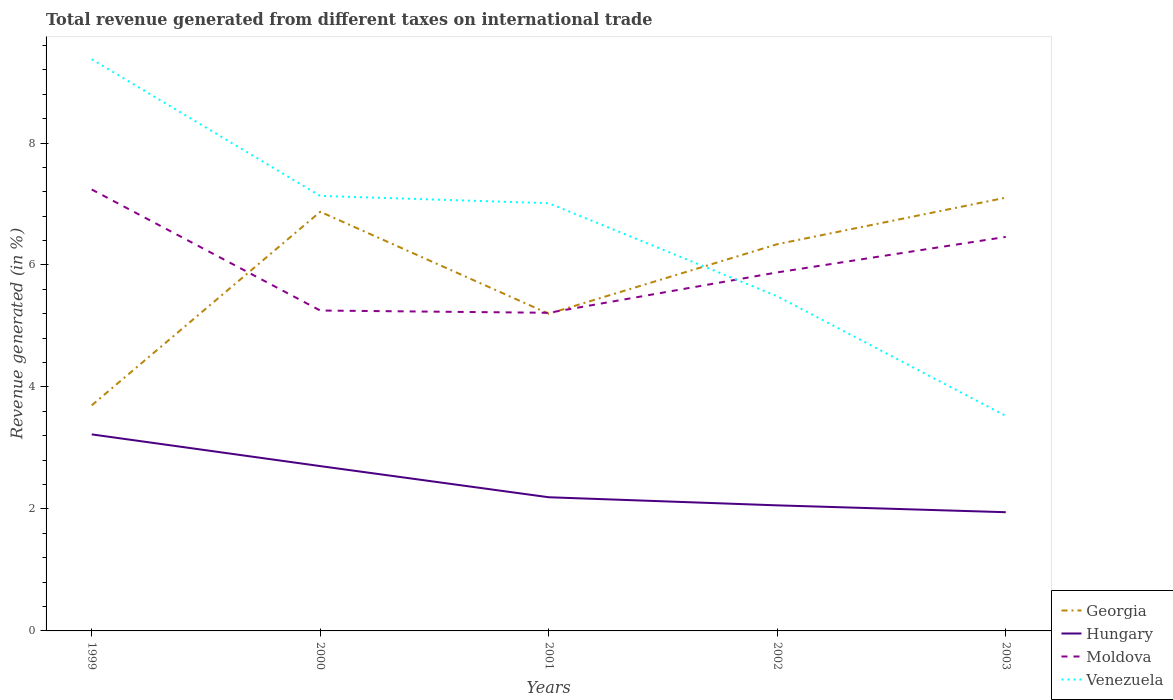How many different coloured lines are there?
Provide a succinct answer. 4. Does the line corresponding to Venezuela intersect with the line corresponding to Georgia?
Offer a terse response. Yes. Across all years, what is the maximum total revenue generated in Georgia?
Offer a very short reply. 3.7. What is the total total revenue generated in Moldova in the graph?
Give a very brief answer. 1.98. What is the difference between the highest and the second highest total revenue generated in Georgia?
Your answer should be compact. 3.41. What is the difference between the highest and the lowest total revenue generated in Venezuela?
Offer a terse response. 3. Is the total revenue generated in Venezuela strictly greater than the total revenue generated in Hungary over the years?
Make the answer very short. No. How many lines are there?
Your answer should be very brief. 4. Where does the legend appear in the graph?
Make the answer very short. Bottom right. How are the legend labels stacked?
Your response must be concise. Vertical. What is the title of the graph?
Give a very brief answer. Total revenue generated from different taxes on international trade. Does "Eritrea" appear as one of the legend labels in the graph?
Provide a short and direct response. No. What is the label or title of the X-axis?
Your response must be concise. Years. What is the label or title of the Y-axis?
Offer a very short reply. Revenue generated (in %). What is the Revenue generated (in %) in Georgia in 1999?
Make the answer very short. 3.7. What is the Revenue generated (in %) in Hungary in 1999?
Your answer should be very brief. 3.22. What is the Revenue generated (in %) in Moldova in 1999?
Your answer should be very brief. 7.24. What is the Revenue generated (in %) in Venezuela in 1999?
Your answer should be compact. 9.37. What is the Revenue generated (in %) in Georgia in 2000?
Your answer should be compact. 6.87. What is the Revenue generated (in %) in Hungary in 2000?
Give a very brief answer. 2.7. What is the Revenue generated (in %) in Moldova in 2000?
Keep it short and to the point. 5.25. What is the Revenue generated (in %) in Venezuela in 2000?
Keep it short and to the point. 7.13. What is the Revenue generated (in %) in Georgia in 2001?
Provide a succinct answer. 5.2. What is the Revenue generated (in %) of Hungary in 2001?
Keep it short and to the point. 2.19. What is the Revenue generated (in %) in Moldova in 2001?
Ensure brevity in your answer.  5.22. What is the Revenue generated (in %) in Venezuela in 2001?
Give a very brief answer. 7.01. What is the Revenue generated (in %) in Georgia in 2002?
Make the answer very short. 6.34. What is the Revenue generated (in %) of Hungary in 2002?
Your answer should be very brief. 2.06. What is the Revenue generated (in %) of Moldova in 2002?
Offer a terse response. 5.88. What is the Revenue generated (in %) of Venezuela in 2002?
Make the answer very short. 5.49. What is the Revenue generated (in %) of Georgia in 2003?
Keep it short and to the point. 7.1. What is the Revenue generated (in %) in Hungary in 2003?
Offer a terse response. 1.95. What is the Revenue generated (in %) of Moldova in 2003?
Offer a terse response. 6.46. What is the Revenue generated (in %) of Venezuela in 2003?
Provide a short and direct response. 3.53. Across all years, what is the maximum Revenue generated (in %) of Georgia?
Make the answer very short. 7.1. Across all years, what is the maximum Revenue generated (in %) in Hungary?
Your answer should be compact. 3.22. Across all years, what is the maximum Revenue generated (in %) in Moldova?
Offer a very short reply. 7.24. Across all years, what is the maximum Revenue generated (in %) of Venezuela?
Offer a very short reply. 9.37. Across all years, what is the minimum Revenue generated (in %) in Georgia?
Your answer should be very brief. 3.7. Across all years, what is the minimum Revenue generated (in %) in Hungary?
Give a very brief answer. 1.95. Across all years, what is the minimum Revenue generated (in %) in Moldova?
Offer a very short reply. 5.22. Across all years, what is the minimum Revenue generated (in %) of Venezuela?
Provide a short and direct response. 3.53. What is the total Revenue generated (in %) of Georgia in the graph?
Offer a terse response. 29.22. What is the total Revenue generated (in %) of Hungary in the graph?
Make the answer very short. 12.12. What is the total Revenue generated (in %) in Moldova in the graph?
Offer a very short reply. 30.05. What is the total Revenue generated (in %) in Venezuela in the graph?
Your answer should be very brief. 32.53. What is the difference between the Revenue generated (in %) in Georgia in 1999 and that in 2000?
Ensure brevity in your answer.  -3.17. What is the difference between the Revenue generated (in %) of Hungary in 1999 and that in 2000?
Make the answer very short. 0.52. What is the difference between the Revenue generated (in %) of Moldova in 1999 and that in 2000?
Ensure brevity in your answer.  1.98. What is the difference between the Revenue generated (in %) in Venezuela in 1999 and that in 2000?
Your answer should be very brief. 2.24. What is the difference between the Revenue generated (in %) of Georgia in 1999 and that in 2001?
Provide a succinct answer. -1.5. What is the difference between the Revenue generated (in %) of Hungary in 1999 and that in 2001?
Give a very brief answer. 1.03. What is the difference between the Revenue generated (in %) of Moldova in 1999 and that in 2001?
Make the answer very short. 2.02. What is the difference between the Revenue generated (in %) of Venezuela in 1999 and that in 2001?
Make the answer very short. 2.36. What is the difference between the Revenue generated (in %) in Georgia in 1999 and that in 2002?
Give a very brief answer. -2.64. What is the difference between the Revenue generated (in %) of Hungary in 1999 and that in 2002?
Offer a very short reply. 1.16. What is the difference between the Revenue generated (in %) in Moldova in 1999 and that in 2002?
Offer a terse response. 1.36. What is the difference between the Revenue generated (in %) of Venezuela in 1999 and that in 2002?
Make the answer very short. 3.89. What is the difference between the Revenue generated (in %) of Georgia in 1999 and that in 2003?
Offer a terse response. -3.41. What is the difference between the Revenue generated (in %) of Hungary in 1999 and that in 2003?
Give a very brief answer. 1.28. What is the difference between the Revenue generated (in %) of Moldova in 1999 and that in 2003?
Ensure brevity in your answer.  0.78. What is the difference between the Revenue generated (in %) of Venezuela in 1999 and that in 2003?
Give a very brief answer. 5.85. What is the difference between the Revenue generated (in %) in Georgia in 2000 and that in 2001?
Your answer should be compact. 1.67. What is the difference between the Revenue generated (in %) of Hungary in 2000 and that in 2001?
Offer a very short reply. 0.51. What is the difference between the Revenue generated (in %) in Moldova in 2000 and that in 2001?
Keep it short and to the point. 0.04. What is the difference between the Revenue generated (in %) in Venezuela in 2000 and that in 2001?
Make the answer very short. 0.12. What is the difference between the Revenue generated (in %) in Georgia in 2000 and that in 2002?
Keep it short and to the point. 0.53. What is the difference between the Revenue generated (in %) in Hungary in 2000 and that in 2002?
Ensure brevity in your answer.  0.64. What is the difference between the Revenue generated (in %) in Moldova in 2000 and that in 2002?
Your response must be concise. -0.63. What is the difference between the Revenue generated (in %) of Venezuela in 2000 and that in 2002?
Your answer should be compact. 1.65. What is the difference between the Revenue generated (in %) in Georgia in 2000 and that in 2003?
Give a very brief answer. -0.23. What is the difference between the Revenue generated (in %) of Hungary in 2000 and that in 2003?
Your answer should be compact. 0.76. What is the difference between the Revenue generated (in %) in Moldova in 2000 and that in 2003?
Offer a terse response. -1.21. What is the difference between the Revenue generated (in %) in Venezuela in 2000 and that in 2003?
Provide a succinct answer. 3.61. What is the difference between the Revenue generated (in %) of Georgia in 2001 and that in 2002?
Keep it short and to the point. -1.14. What is the difference between the Revenue generated (in %) in Hungary in 2001 and that in 2002?
Provide a short and direct response. 0.13. What is the difference between the Revenue generated (in %) in Moldova in 2001 and that in 2002?
Your answer should be compact. -0.66. What is the difference between the Revenue generated (in %) of Venezuela in 2001 and that in 2002?
Provide a succinct answer. 1.53. What is the difference between the Revenue generated (in %) in Georgia in 2001 and that in 2003?
Give a very brief answer. -1.9. What is the difference between the Revenue generated (in %) of Hungary in 2001 and that in 2003?
Provide a short and direct response. 0.25. What is the difference between the Revenue generated (in %) of Moldova in 2001 and that in 2003?
Your response must be concise. -1.24. What is the difference between the Revenue generated (in %) in Venezuela in 2001 and that in 2003?
Provide a short and direct response. 3.49. What is the difference between the Revenue generated (in %) of Georgia in 2002 and that in 2003?
Your response must be concise. -0.76. What is the difference between the Revenue generated (in %) in Hungary in 2002 and that in 2003?
Your answer should be very brief. 0.11. What is the difference between the Revenue generated (in %) in Moldova in 2002 and that in 2003?
Keep it short and to the point. -0.58. What is the difference between the Revenue generated (in %) in Venezuela in 2002 and that in 2003?
Make the answer very short. 1.96. What is the difference between the Revenue generated (in %) of Georgia in 1999 and the Revenue generated (in %) of Hungary in 2000?
Make the answer very short. 1. What is the difference between the Revenue generated (in %) of Georgia in 1999 and the Revenue generated (in %) of Moldova in 2000?
Ensure brevity in your answer.  -1.55. What is the difference between the Revenue generated (in %) in Georgia in 1999 and the Revenue generated (in %) in Venezuela in 2000?
Your answer should be compact. -3.43. What is the difference between the Revenue generated (in %) of Hungary in 1999 and the Revenue generated (in %) of Moldova in 2000?
Your response must be concise. -2.03. What is the difference between the Revenue generated (in %) in Hungary in 1999 and the Revenue generated (in %) in Venezuela in 2000?
Your response must be concise. -3.91. What is the difference between the Revenue generated (in %) of Moldova in 1999 and the Revenue generated (in %) of Venezuela in 2000?
Your answer should be compact. 0.11. What is the difference between the Revenue generated (in %) of Georgia in 1999 and the Revenue generated (in %) of Hungary in 2001?
Make the answer very short. 1.51. What is the difference between the Revenue generated (in %) in Georgia in 1999 and the Revenue generated (in %) in Moldova in 2001?
Make the answer very short. -1.52. What is the difference between the Revenue generated (in %) of Georgia in 1999 and the Revenue generated (in %) of Venezuela in 2001?
Make the answer very short. -3.31. What is the difference between the Revenue generated (in %) of Hungary in 1999 and the Revenue generated (in %) of Moldova in 2001?
Give a very brief answer. -1.99. What is the difference between the Revenue generated (in %) in Hungary in 1999 and the Revenue generated (in %) in Venezuela in 2001?
Offer a terse response. -3.79. What is the difference between the Revenue generated (in %) in Moldova in 1999 and the Revenue generated (in %) in Venezuela in 2001?
Give a very brief answer. 0.22. What is the difference between the Revenue generated (in %) in Georgia in 1999 and the Revenue generated (in %) in Hungary in 2002?
Offer a terse response. 1.64. What is the difference between the Revenue generated (in %) of Georgia in 1999 and the Revenue generated (in %) of Moldova in 2002?
Make the answer very short. -2.18. What is the difference between the Revenue generated (in %) in Georgia in 1999 and the Revenue generated (in %) in Venezuela in 2002?
Offer a terse response. -1.79. What is the difference between the Revenue generated (in %) of Hungary in 1999 and the Revenue generated (in %) of Moldova in 2002?
Ensure brevity in your answer.  -2.66. What is the difference between the Revenue generated (in %) of Hungary in 1999 and the Revenue generated (in %) of Venezuela in 2002?
Your response must be concise. -2.26. What is the difference between the Revenue generated (in %) of Moldova in 1999 and the Revenue generated (in %) of Venezuela in 2002?
Offer a very short reply. 1.75. What is the difference between the Revenue generated (in %) of Georgia in 1999 and the Revenue generated (in %) of Hungary in 2003?
Your answer should be compact. 1.75. What is the difference between the Revenue generated (in %) of Georgia in 1999 and the Revenue generated (in %) of Moldova in 2003?
Provide a short and direct response. -2.76. What is the difference between the Revenue generated (in %) of Georgia in 1999 and the Revenue generated (in %) of Venezuela in 2003?
Your answer should be very brief. 0.17. What is the difference between the Revenue generated (in %) of Hungary in 1999 and the Revenue generated (in %) of Moldova in 2003?
Provide a short and direct response. -3.24. What is the difference between the Revenue generated (in %) in Hungary in 1999 and the Revenue generated (in %) in Venezuela in 2003?
Keep it short and to the point. -0.3. What is the difference between the Revenue generated (in %) in Moldova in 1999 and the Revenue generated (in %) in Venezuela in 2003?
Ensure brevity in your answer.  3.71. What is the difference between the Revenue generated (in %) in Georgia in 2000 and the Revenue generated (in %) in Hungary in 2001?
Your answer should be very brief. 4.68. What is the difference between the Revenue generated (in %) of Georgia in 2000 and the Revenue generated (in %) of Moldova in 2001?
Ensure brevity in your answer.  1.66. What is the difference between the Revenue generated (in %) of Georgia in 2000 and the Revenue generated (in %) of Venezuela in 2001?
Your answer should be compact. -0.14. What is the difference between the Revenue generated (in %) in Hungary in 2000 and the Revenue generated (in %) in Moldova in 2001?
Offer a terse response. -2.51. What is the difference between the Revenue generated (in %) in Hungary in 2000 and the Revenue generated (in %) in Venezuela in 2001?
Provide a succinct answer. -4.31. What is the difference between the Revenue generated (in %) of Moldova in 2000 and the Revenue generated (in %) of Venezuela in 2001?
Give a very brief answer. -1.76. What is the difference between the Revenue generated (in %) of Georgia in 2000 and the Revenue generated (in %) of Hungary in 2002?
Your response must be concise. 4.81. What is the difference between the Revenue generated (in %) in Georgia in 2000 and the Revenue generated (in %) in Moldova in 2002?
Provide a succinct answer. 0.99. What is the difference between the Revenue generated (in %) of Georgia in 2000 and the Revenue generated (in %) of Venezuela in 2002?
Offer a very short reply. 1.39. What is the difference between the Revenue generated (in %) of Hungary in 2000 and the Revenue generated (in %) of Moldova in 2002?
Provide a short and direct response. -3.18. What is the difference between the Revenue generated (in %) of Hungary in 2000 and the Revenue generated (in %) of Venezuela in 2002?
Your response must be concise. -2.78. What is the difference between the Revenue generated (in %) of Moldova in 2000 and the Revenue generated (in %) of Venezuela in 2002?
Your answer should be very brief. -0.23. What is the difference between the Revenue generated (in %) of Georgia in 2000 and the Revenue generated (in %) of Hungary in 2003?
Your answer should be very brief. 4.93. What is the difference between the Revenue generated (in %) of Georgia in 2000 and the Revenue generated (in %) of Moldova in 2003?
Keep it short and to the point. 0.41. What is the difference between the Revenue generated (in %) in Georgia in 2000 and the Revenue generated (in %) in Venezuela in 2003?
Your answer should be compact. 3.35. What is the difference between the Revenue generated (in %) in Hungary in 2000 and the Revenue generated (in %) in Moldova in 2003?
Your answer should be very brief. -3.76. What is the difference between the Revenue generated (in %) of Hungary in 2000 and the Revenue generated (in %) of Venezuela in 2003?
Your answer should be very brief. -0.82. What is the difference between the Revenue generated (in %) in Moldova in 2000 and the Revenue generated (in %) in Venezuela in 2003?
Keep it short and to the point. 1.73. What is the difference between the Revenue generated (in %) of Georgia in 2001 and the Revenue generated (in %) of Hungary in 2002?
Provide a succinct answer. 3.14. What is the difference between the Revenue generated (in %) of Georgia in 2001 and the Revenue generated (in %) of Moldova in 2002?
Ensure brevity in your answer.  -0.68. What is the difference between the Revenue generated (in %) in Georgia in 2001 and the Revenue generated (in %) in Venezuela in 2002?
Your answer should be very brief. -0.29. What is the difference between the Revenue generated (in %) of Hungary in 2001 and the Revenue generated (in %) of Moldova in 2002?
Your answer should be compact. -3.69. What is the difference between the Revenue generated (in %) of Hungary in 2001 and the Revenue generated (in %) of Venezuela in 2002?
Give a very brief answer. -3.29. What is the difference between the Revenue generated (in %) of Moldova in 2001 and the Revenue generated (in %) of Venezuela in 2002?
Offer a terse response. -0.27. What is the difference between the Revenue generated (in %) in Georgia in 2001 and the Revenue generated (in %) in Hungary in 2003?
Give a very brief answer. 3.25. What is the difference between the Revenue generated (in %) of Georgia in 2001 and the Revenue generated (in %) of Moldova in 2003?
Give a very brief answer. -1.26. What is the difference between the Revenue generated (in %) in Georgia in 2001 and the Revenue generated (in %) in Venezuela in 2003?
Your answer should be compact. 1.67. What is the difference between the Revenue generated (in %) of Hungary in 2001 and the Revenue generated (in %) of Moldova in 2003?
Give a very brief answer. -4.27. What is the difference between the Revenue generated (in %) in Hungary in 2001 and the Revenue generated (in %) in Venezuela in 2003?
Offer a terse response. -1.33. What is the difference between the Revenue generated (in %) in Moldova in 2001 and the Revenue generated (in %) in Venezuela in 2003?
Offer a very short reply. 1.69. What is the difference between the Revenue generated (in %) in Georgia in 2002 and the Revenue generated (in %) in Hungary in 2003?
Provide a succinct answer. 4.39. What is the difference between the Revenue generated (in %) of Georgia in 2002 and the Revenue generated (in %) of Moldova in 2003?
Make the answer very short. -0.12. What is the difference between the Revenue generated (in %) in Georgia in 2002 and the Revenue generated (in %) in Venezuela in 2003?
Ensure brevity in your answer.  2.82. What is the difference between the Revenue generated (in %) of Hungary in 2002 and the Revenue generated (in %) of Moldova in 2003?
Offer a terse response. -4.4. What is the difference between the Revenue generated (in %) in Hungary in 2002 and the Revenue generated (in %) in Venezuela in 2003?
Your answer should be compact. -1.47. What is the difference between the Revenue generated (in %) of Moldova in 2002 and the Revenue generated (in %) of Venezuela in 2003?
Your answer should be compact. 2.35. What is the average Revenue generated (in %) of Georgia per year?
Provide a succinct answer. 5.84. What is the average Revenue generated (in %) of Hungary per year?
Keep it short and to the point. 2.42. What is the average Revenue generated (in %) of Moldova per year?
Offer a very short reply. 6.01. What is the average Revenue generated (in %) in Venezuela per year?
Provide a short and direct response. 6.51. In the year 1999, what is the difference between the Revenue generated (in %) of Georgia and Revenue generated (in %) of Hungary?
Provide a succinct answer. 0.48. In the year 1999, what is the difference between the Revenue generated (in %) of Georgia and Revenue generated (in %) of Moldova?
Provide a short and direct response. -3.54. In the year 1999, what is the difference between the Revenue generated (in %) in Georgia and Revenue generated (in %) in Venezuela?
Give a very brief answer. -5.68. In the year 1999, what is the difference between the Revenue generated (in %) in Hungary and Revenue generated (in %) in Moldova?
Provide a short and direct response. -4.02. In the year 1999, what is the difference between the Revenue generated (in %) of Hungary and Revenue generated (in %) of Venezuela?
Your answer should be compact. -6.15. In the year 1999, what is the difference between the Revenue generated (in %) of Moldova and Revenue generated (in %) of Venezuela?
Offer a very short reply. -2.14. In the year 2000, what is the difference between the Revenue generated (in %) in Georgia and Revenue generated (in %) in Hungary?
Your answer should be compact. 4.17. In the year 2000, what is the difference between the Revenue generated (in %) in Georgia and Revenue generated (in %) in Moldova?
Your answer should be compact. 1.62. In the year 2000, what is the difference between the Revenue generated (in %) in Georgia and Revenue generated (in %) in Venezuela?
Provide a short and direct response. -0.26. In the year 2000, what is the difference between the Revenue generated (in %) in Hungary and Revenue generated (in %) in Moldova?
Offer a very short reply. -2.55. In the year 2000, what is the difference between the Revenue generated (in %) of Hungary and Revenue generated (in %) of Venezuela?
Your answer should be very brief. -4.43. In the year 2000, what is the difference between the Revenue generated (in %) of Moldova and Revenue generated (in %) of Venezuela?
Your response must be concise. -1.88. In the year 2001, what is the difference between the Revenue generated (in %) in Georgia and Revenue generated (in %) in Hungary?
Your response must be concise. 3.01. In the year 2001, what is the difference between the Revenue generated (in %) in Georgia and Revenue generated (in %) in Moldova?
Your answer should be compact. -0.02. In the year 2001, what is the difference between the Revenue generated (in %) in Georgia and Revenue generated (in %) in Venezuela?
Make the answer very short. -1.81. In the year 2001, what is the difference between the Revenue generated (in %) in Hungary and Revenue generated (in %) in Moldova?
Provide a succinct answer. -3.02. In the year 2001, what is the difference between the Revenue generated (in %) of Hungary and Revenue generated (in %) of Venezuela?
Keep it short and to the point. -4.82. In the year 2001, what is the difference between the Revenue generated (in %) in Moldova and Revenue generated (in %) in Venezuela?
Your answer should be compact. -1.8. In the year 2002, what is the difference between the Revenue generated (in %) in Georgia and Revenue generated (in %) in Hungary?
Provide a short and direct response. 4.28. In the year 2002, what is the difference between the Revenue generated (in %) of Georgia and Revenue generated (in %) of Moldova?
Give a very brief answer. 0.46. In the year 2002, what is the difference between the Revenue generated (in %) in Georgia and Revenue generated (in %) in Venezuela?
Make the answer very short. 0.85. In the year 2002, what is the difference between the Revenue generated (in %) in Hungary and Revenue generated (in %) in Moldova?
Offer a terse response. -3.82. In the year 2002, what is the difference between the Revenue generated (in %) in Hungary and Revenue generated (in %) in Venezuela?
Your answer should be compact. -3.43. In the year 2002, what is the difference between the Revenue generated (in %) in Moldova and Revenue generated (in %) in Venezuela?
Offer a terse response. 0.39. In the year 2003, what is the difference between the Revenue generated (in %) of Georgia and Revenue generated (in %) of Hungary?
Ensure brevity in your answer.  5.16. In the year 2003, what is the difference between the Revenue generated (in %) of Georgia and Revenue generated (in %) of Moldova?
Ensure brevity in your answer.  0.64. In the year 2003, what is the difference between the Revenue generated (in %) in Georgia and Revenue generated (in %) in Venezuela?
Your response must be concise. 3.58. In the year 2003, what is the difference between the Revenue generated (in %) in Hungary and Revenue generated (in %) in Moldova?
Offer a very short reply. -4.51. In the year 2003, what is the difference between the Revenue generated (in %) of Hungary and Revenue generated (in %) of Venezuela?
Your answer should be very brief. -1.58. In the year 2003, what is the difference between the Revenue generated (in %) of Moldova and Revenue generated (in %) of Venezuela?
Provide a succinct answer. 2.93. What is the ratio of the Revenue generated (in %) of Georgia in 1999 to that in 2000?
Give a very brief answer. 0.54. What is the ratio of the Revenue generated (in %) of Hungary in 1999 to that in 2000?
Provide a short and direct response. 1.19. What is the ratio of the Revenue generated (in %) in Moldova in 1999 to that in 2000?
Your response must be concise. 1.38. What is the ratio of the Revenue generated (in %) in Venezuela in 1999 to that in 2000?
Your response must be concise. 1.31. What is the ratio of the Revenue generated (in %) in Georgia in 1999 to that in 2001?
Ensure brevity in your answer.  0.71. What is the ratio of the Revenue generated (in %) of Hungary in 1999 to that in 2001?
Offer a terse response. 1.47. What is the ratio of the Revenue generated (in %) of Moldova in 1999 to that in 2001?
Offer a terse response. 1.39. What is the ratio of the Revenue generated (in %) of Venezuela in 1999 to that in 2001?
Your answer should be very brief. 1.34. What is the ratio of the Revenue generated (in %) in Georgia in 1999 to that in 2002?
Your answer should be compact. 0.58. What is the ratio of the Revenue generated (in %) in Hungary in 1999 to that in 2002?
Make the answer very short. 1.57. What is the ratio of the Revenue generated (in %) in Moldova in 1999 to that in 2002?
Your answer should be compact. 1.23. What is the ratio of the Revenue generated (in %) of Venezuela in 1999 to that in 2002?
Provide a short and direct response. 1.71. What is the ratio of the Revenue generated (in %) in Georgia in 1999 to that in 2003?
Make the answer very short. 0.52. What is the ratio of the Revenue generated (in %) of Hungary in 1999 to that in 2003?
Give a very brief answer. 1.66. What is the ratio of the Revenue generated (in %) of Moldova in 1999 to that in 2003?
Ensure brevity in your answer.  1.12. What is the ratio of the Revenue generated (in %) in Venezuela in 1999 to that in 2003?
Keep it short and to the point. 2.66. What is the ratio of the Revenue generated (in %) in Georgia in 2000 to that in 2001?
Your response must be concise. 1.32. What is the ratio of the Revenue generated (in %) in Hungary in 2000 to that in 2001?
Provide a short and direct response. 1.23. What is the ratio of the Revenue generated (in %) in Moldova in 2000 to that in 2001?
Offer a terse response. 1.01. What is the ratio of the Revenue generated (in %) of Georgia in 2000 to that in 2002?
Offer a terse response. 1.08. What is the ratio of the Revenue generated (in %) in Hungary in 2000 to that in 2002?
Make the answer very short. 1.31. What is the ratio of the Revenue generated (in %) of Moldova in 2000 to that in 2002?
Ensure brevity in your answer.  0.89. What is the ratio of the Revenue generated (in %) of Venezuela in 2000 to that in 2002?
Keep it short and to the point. 1.3. What is the ratio of the Revenue generated (in %) of Georgia in 2000 to that in 2003?
Make the answer very short. 0.97. What is the ratio of the Revenue generated (in %) in Hungary in 2000 to that in 2003?
Your answer should be very brief. 1.39. What is the ratio of the Revenue generated (in %) in Moldova in 2000 to that in 2003?
Offer a terse response. 0.81. What is the ratio of the Revenue generated (in %) in Venezuela in 2000 to that in 2003?
Ensure brevity in your answer.  2.02. What is the ratio of the Revenue generated (in %) in Georgia in 2001 to that in 2002?
Make the answer very short. 0.82. What is the ratio of the Revenue generated (in %) in Hungary in 2001 to that in 2002?
Give a very brief answer. 1.06. What is the ratio of the Revenue generated (in %) of Moldova in 2001 to that in 2002?
Your response must be concise. 0.89. What is the ratio of the Revenue generated (in %) in Venezuela in 2001 to that in 2002?
Keep it short and to the point. 1.28. What is the ratio of the Revenue generated (in %) of Georgia in 2001 to that in 2003?
Ensure brevity in your answer.  0.73. What is the ratio of the Revenue generated (in %) of Hungary in 2001 to that in 2003?
Ensure brevity in your answer.  1.13. What is the ratio of the Revenue generated (in %) of Moldova in 2001 to that in 2003?
Offer a very short reply. 0.81. What is the ratio of the Revenue generated (in %) of Venezuela in 2001 to that in 2003?
Give a very brief answer. 1.99. What is the ratio of the Revenue generated (in %) in Georgia in 2002 to that in 2003?
Provide a succinct answer. 0.89. What is the ratio of the Revenue generated (in %) of Hungary in 2002 to that in 2003?
Ensure brevity in your answer.  1.06. What is the ratio of the Revenue generated (in %) of Moldova in 2002 to that in 2003?
Make the answer very short. 0.91. What is the ratio of the Revenue generated (in %) in Venezuela in 2002 to that in 2003?
Offer a very short reply. 1.56. What is the difference between the highest and the second highest Revenue generated (in %) in Georgia?
Keep it short and to the point. 0.23. What is the difference between the highest and the second highest Revenue generated (in %) of Hungary?
Offer a terse response. 0.52. What is the difference between the highest and the second highest Revenue generated (in %) in Moldova?
Provide a short and direct response. 0.78. What is the difference between the highest and the second highest Revenue generated (in %) in Venezuela?
Keep it short and to the point. 2.24. What is the difference between the highest and the lowest Revenue generated (in %) of Georgia?
Your answer should be compact. 3.41. What is the difference between the highest and the lowest Revenue generated (in %) in Hungary?
Make the answer very short. 1.28. What is the difference between the highest and the lowest Revenue generated (in %) in Moldova?
Your answer should be compact. 2.02. What is the difference between the highest and the lowest Revenue generated (in %) in Venezuela?
Provide a succinct answer. 5.85. 